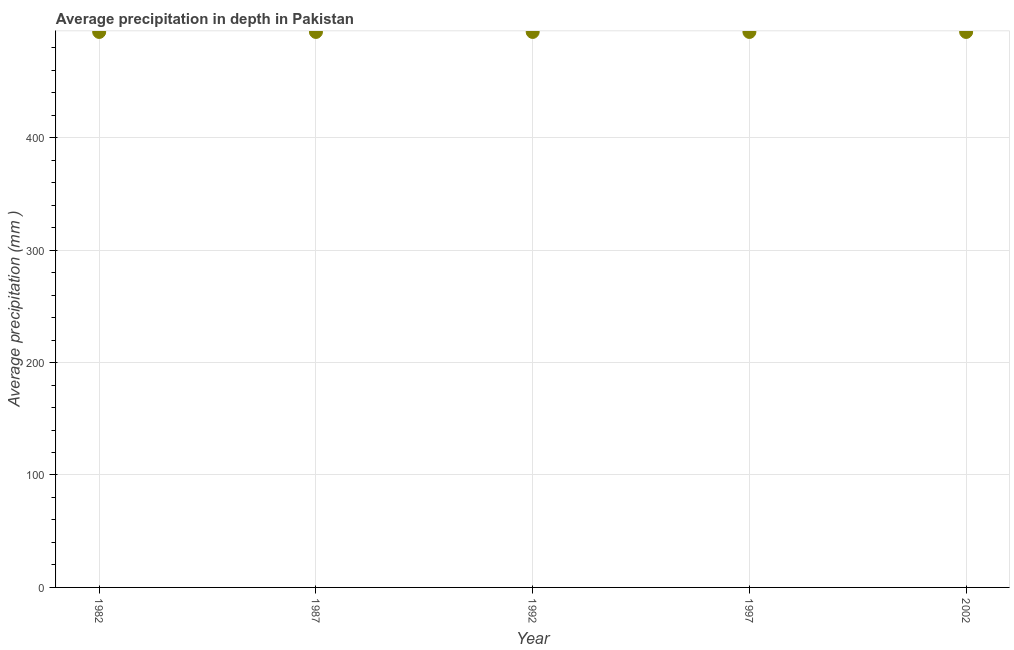What is the average precipitation in depth in 1992?
Your answer should be compact. 494. Across all years, what is the maximum average precipitation in depth?
Give a very brief answer. 494. Across all years, what is the minimum average precipitation in depth?
Give a very brief answer. 494. In which year was the average precipitation in depth minimum?
Your answer should be very brief. 1982. What is the sum of the average precipitation in depth?
Keep it short and to the point. 2470. What is the average average precipitation in depth per year?
Ensure brevity in your answer.  494. What is the median average precipitation in depth?
Ensure brevity in your answer.  494. What is the ratio of the average precipitation in depth in 1997 to that in 2002?
Your response must be concise. 1. Does the average precipitation in depth monotonically increase over the years?
Provide a succinct answer. No. Are the values on the major ticks of Y-axis written in scientific E-notation?
Make the answer very short. No. Does the graph contain any zero values?
Provide a succinct answer. No. Does the graph contain grids?
Your answer should be compact. Yes. What is the title of the graph?
Your answer should be very brief. Average precipitation in depth in Pakistan. What is the label or title of the Y-axis?
Your response must be concise. Average precipitation (mm ). What is the Average precipitation (mm ) in 1982?
Provide a succinct answer. 494. What is the Average precipitation (mm ) in 1987?
Keep it short and to the point. 494. What is the Average precipitation (mm ) in 1992?
Offer a very short reply. 494. What is the Average precipitation (mm ) in 1997?
Offer a terse response. 494. What is the Average precipitation (mm ) in 2002?
Provide a succinct answer. 494. What is the difference between the Average precipitation (mm ) in 1982 and 1997?
Offer a very short reply. 0. What is the difference between the Average precipitation (mm ) in 1992 and 2002?
Provide a succinct answer. 0. What is the difference between the Average precipitation (mm ) in 1997 and 2002?
Offer a terse response. 0. What is the ratio of the Average precipitation (mm ) in 1982 to that in 1987?
Your response must be concise. 1. What is the ratio of the Average precipitation (mm ) in 1982 to that in 1992?
Offer a terse response. 1. What is the ratio of the Average precipitation (mm ) in 1982 to that in 1997?
Your answer should be very brief. 1. What is the ratio of the Average precipitation (mm ) in 1987 to that in 1997?
Offer a very short reply. 1. What is the ratio of the Average precipitation (mm ) in 1987 to that in 2002?
Offer a terse response. 1. What is the ratio of the Average precipitation (mm ) in 1992 to that in 1997?
Your answer should be very brief. 1. What is the ratio of the Average precipitation (mm ) in 1992 to that in 2002?
Your answer should be very brief. 1. What is the ratio of the Average precipitation (mm ) in 1997 to that in 2002?
Your answer should be very brief. 1. 